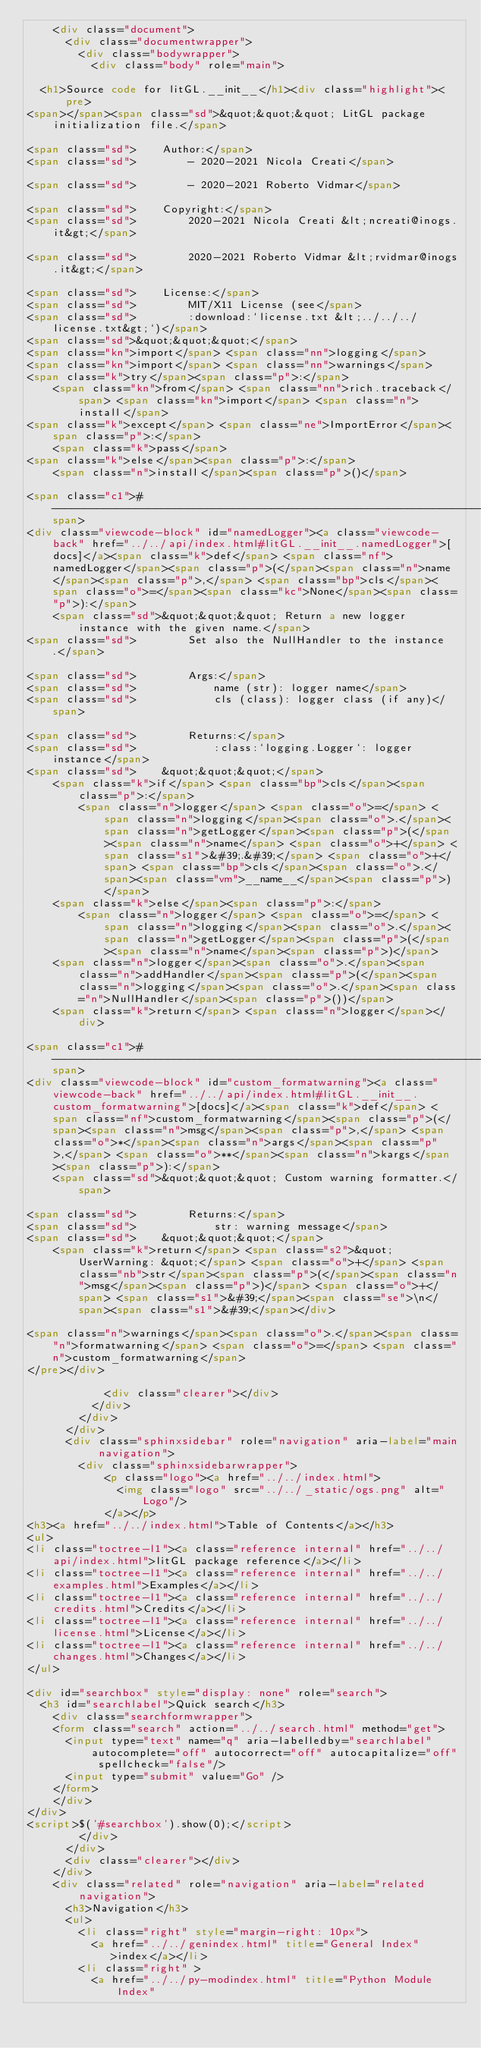<code> <loc_0><loc_0><loc_500><loc_500><_HTML_>    <div class="document">
      <div class="documentwrapper">
        <div class="bodywrapper">
          <div class="body" role="main">
            
  <h1>Source code for litGL.__init__</h1><div class="highlight"><pre>
<span></span><span class="sd">&quot;&quot;&quot; LitGL package initialization file.</span>

<span class="sd">    Author:</span>
<span class="sd">        - 2020-2021 Nicola Creati</span>

<span class="sd">        - 2020-2021 Roberto Vidmar</span>

<span class="sd">    Copyright:</span>
<span class="sd">        2020-2021 Nicola Creati &lt;ncreati@inogs.it&gt;</span>

<span class="sd">        2020-2021 Roberto Vidmar &lt;rvidmar@inogs.it&gt;</span>

<span class="sd">    License:</span>
<span class="sd">        MIT/X11 License (see</span>
<span class="sd">        :download:`license.txt &lt;../../../license.txt&gt;`)</span>
<span class="sd">&quot;&quot;&quot;</span>
<span class="kn">import</span> <span class="nn">logging</span>
<span class="kn">import</span> <span class="nn">warnings</span>
<span class="k">try</span><span class="p">:</span>
    <span class="kn">from</span> <span class="nn">rich.traceback</span> <span class="kn">import</span> <span class="n">install</span>
<span class="k">except</span> <span class="ne">ImportError</span><span class="p">:</span>
    <span class="k">pass</span>
<span class="k">else</span><span class="p">:</span>
    <span class="n">install</span><span class="p">()</span>

<span class="c1"># -----------------------------------------------------------------------------</span>
<div class="viewcode-block" id="namedLogger"><a class="viewcode-back" href="../../api/index.html#litGL.__init__.namedLogger">[docs]</a><span class="k">def</span> <span class="nf">namedLogger</span><span class="p">(</span><span class="n">name</span><span class="p">,</span> <span class="bp">cls</span><span class="o">=</span><span class="kc">None</span><span class="p">):</span>
    <span class="sd">&quot;&quot;&quot; Return a new logger instance with the given name.</span>
<span class="sd">        Set also the NullHandler to the instance.</span>

<span class="sd">        Args:</span>
<span class="sd">            name (str): logger name</span>
<span class="sd">            cls (class): logger class (if any)</span>

<span class="sd">        Returns:</span>
<span class="sd">            :class:`logging.Logger`: logger instance</span>
<span class="sd">    &quot;&quot;&quot;</span>
    <span class="k">if</span> <span class="bp">cls</span><span class="p">:</span>
        <span class="n">logger</span> <span class="o">=</span> <span class="n">logging</span><span class="o">.</span><span class="n">getLogger</span><span class="p">(</span><span class="n">name</span> <span class="o">+</span> <span class="s1">&#39;.&#39;</span> <span class="o">+</span> <span class="bp">cls</span><span class="o">.</span><span class="vm">__name__</span><span class="p">)</span>
    <span class="k">else</span><span class="p">:</span>
        <span class="n">logger</span> <span class="o">=</span> <span class="n">logging</span><span class="o">.</span><span class="n">getLogger</span><span class="p">(</span><span class="n">name</span><span class="p">)</span>
    <span class="n">logger</span><span class="o">.</span><span class="n">addHandler</span><span class="p">(</span><span class="n">logging</span><span class="o">.</span><span class="n">NullHandler</span><span class="p">())</span>
    <span class="k">return</span> <span class="n">logger</span></div>

<span class="c1"># -----------------------------------------------------------------------------</span>
<div class="viewcode-block" id="custom_formatwarning"><a class="viewcode-back" href="../../api/index.html#litGL.__init__.custom_formatwarning">[docs]</a><span class="k">def</span> <span class="nf">custom_formatwarning</span><span class="p">(</span><span class="n">msg</span><span class="p">,</span> <span class="o">*</span><span class="n">args</span><span class="p">,</span> <span class="o">**</span><span class="n">kargs</span><span class="p">):</span>
    <span class="sd">&quot;&quot;&quot; Custom warning formatter.</span>

<span class="sd">        Returns:</span>
<span class="sd">            str: warning message</span>
<span class="sd">    &quot;&quot;&quot;</span>
    <span class="k">return</span> <span class="s2">&quot;UserWarning: &quot;</span> <span class="o">+</span> <span class="nb">str</span><span class="p">(</span><span class="n">msg</span><span class="p">)</span> <span class="o">+</span> <span class="s1">&#39;</span><span class="se">\n</span><span class="s1">&#39;</span></div>

<span class="n">warnings</span><span class="o">.</span><span class="n">formatwarning</span> <span class="o">=</span> <span class="n">custom_formatwarning</span>
</pre></div>

            <div class="clearer"></div>
          </div>
        </div>
      </div>
      <div class="sphinxsidebar" role="navigation" aria-label="main navigation">
        <div class="sphinxsidebarwrapper">
            <p class="logo"><a href="../../index.html">
              <img class="logo" src="../../_static/ogs.png" alt="Logo"/>
            </a></p>
<h3><a href="../../index.html">Table of Contents</a></h3>
<ul>
<li class="toctree-l1"><a class="reference internal" href="../../api/index.html">litGL package reference</a></li>
<li class="toctree-l1"><a class="reference internal" href="../../examples.html">Examples</a></li>
<li class="toctree-l1"><a class="reference internal" href="../../credits.html">Credits</a></li>
<li class="toctree-l1"><a class="reference internal" href="../../license.html">License</a></li>
<li class="toctree-l1"><a class="reference internal" href="../../changes.html">Changes</a></li>
</ul>

<div id="searchbox" style="display: none" role="search">
  <h3 id="searchlabel">Quick search</h3>
    <div class="searchformwrapper">
    <form class="search" action="../../search.html" method="get">
      <input type="text" name="q" aria-labelledby="searchlabel" autocomplete="off" autocorrect="off" autocapitalize="off" spellcheck="false"/>
      <input type="submit" value="Go" />
    </form>
    </div>
</div>
<script>$('#searchbox').show(0);</script>
        </div>
      </div>
      <div class="clearer"></div>
    </div>
    <div class="related" role="navigation" aria-label="related navigation">
      <h3>Navigation</h3>
      <ul>
        <li class="right" style="margin-right: 10px">
          <a href="../../genindex.html" title="General Index"
             >index</a></li>
        <li class="right" >
          <a href="../../py-modindex.html" title="Python Module Index"</code> 